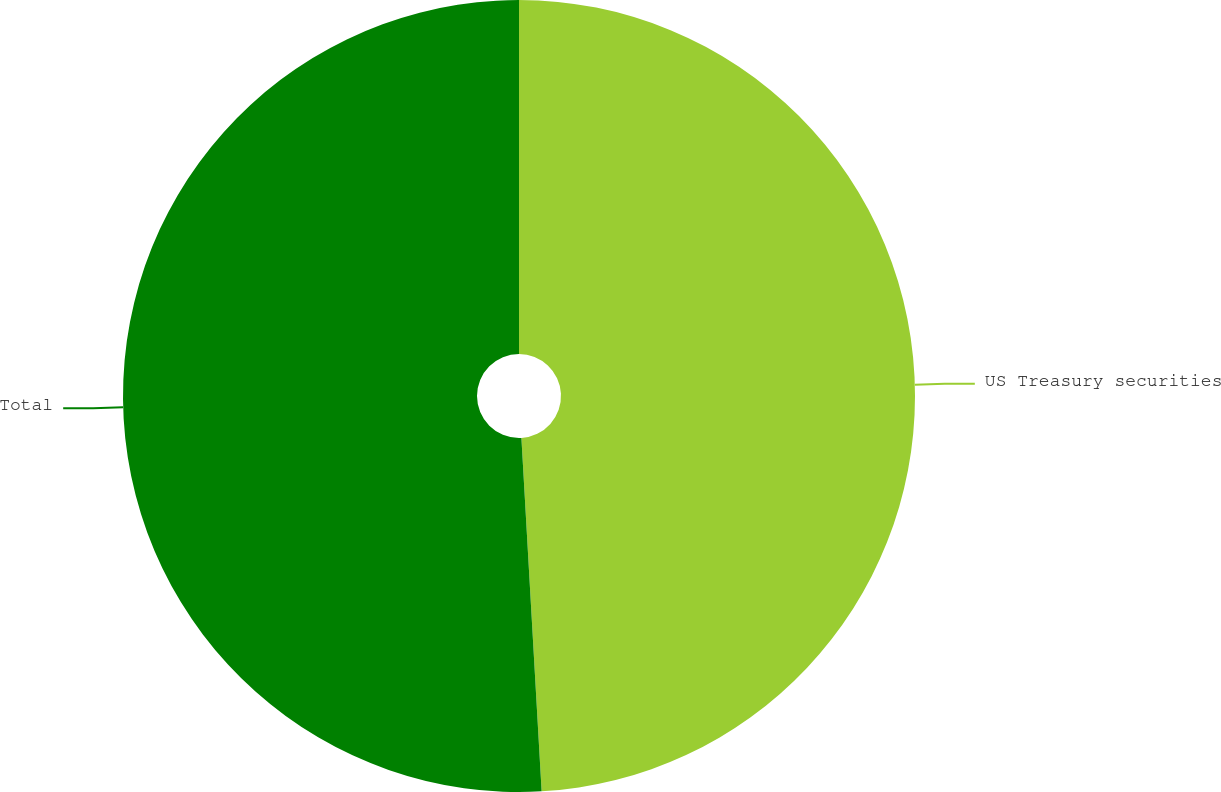Convert chart to OTSL. <chart><loc_0><loc_0><loc_500><loc_500><pie_chart><fcel>US Treasury securities<fcel>Total<nl><fcel>49.09%<fcel>50.91%<nl></chart> 